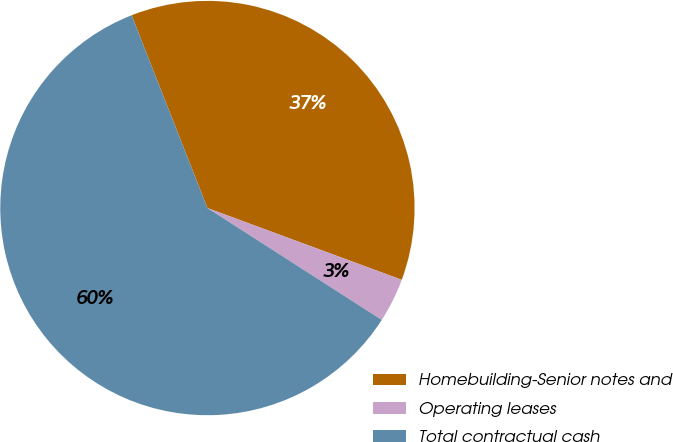Convert chart to OTSL. <chart><loc_0><loc_0><loc_500><loc_500><pie_chart><fcel>Homebuilding-Senior notes and<fcel>Operating leases<fcel>Total contractual cash<nl><fcel>36.59%<fcel>3.45%<fcel>59.95%<nl></chart> 